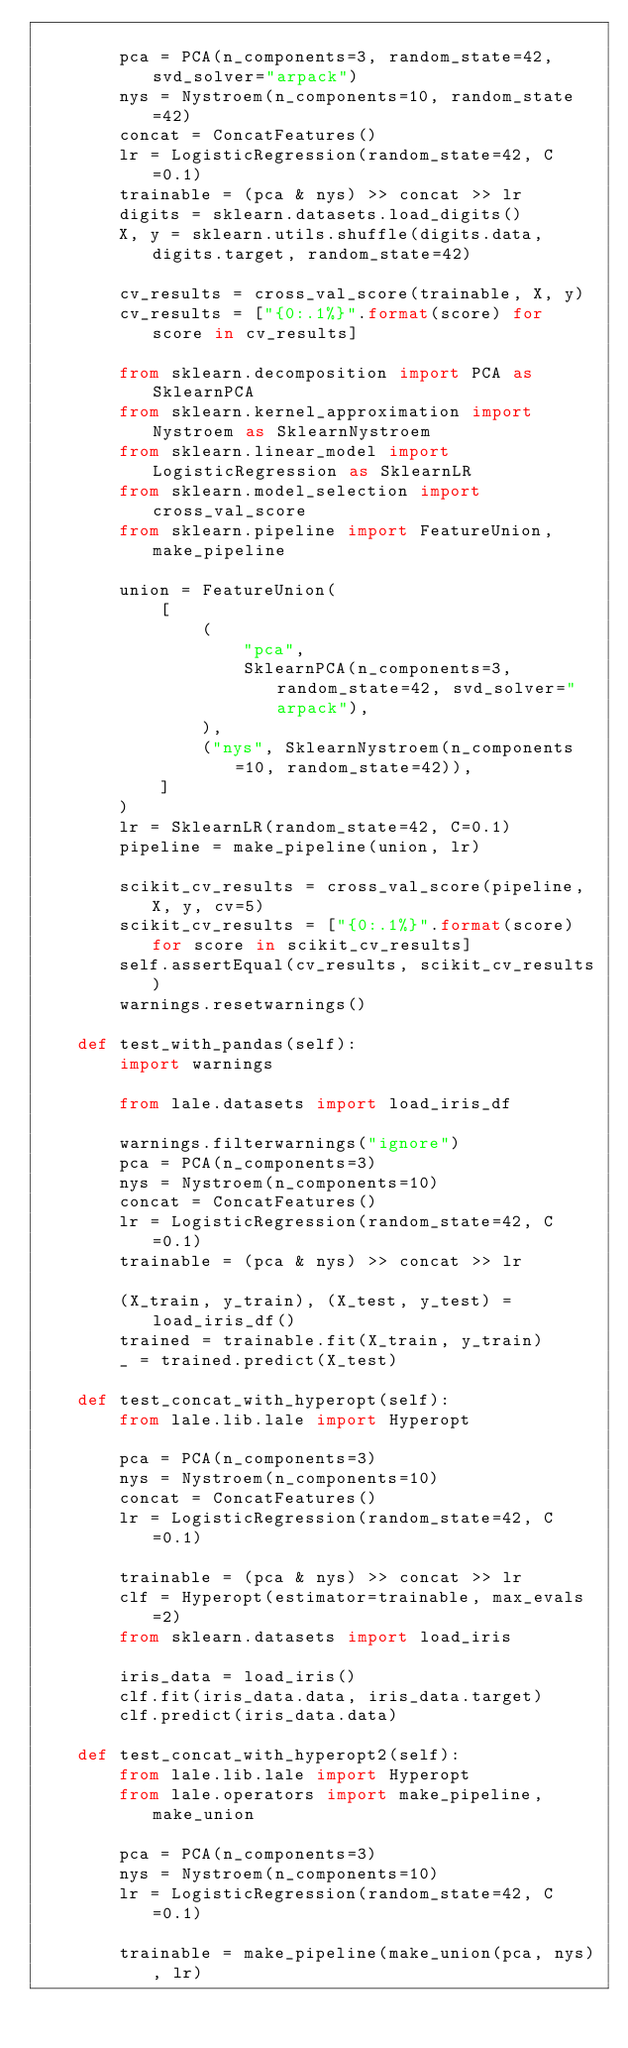Convert code to text. <code><loc_0><loc_0><loc_500><loc_500><_Python_>
        pca = PCA(n_components=3, random_state=42, svd_solver="arpack")
        nys = Nystroem(n_components=10, random_state=42)
        concat = ConcatFeatures()
        lr = LogisticRegression(random_state=42, C=0.1)
        trainable = (pca & nys) >> concat >> lr
        digits = sklearn.datasets.load_digits()
        X, y = sklearn.utils.shuffle(digits.data, digits.target, random_state=42)

        cv_results = cross_val_score(trainable, X, y)
        cv_results = ["{0:.1%}".format(score) for score in cv_results]

        from sklearn.decomposition import PCA as SklearnPCA
        from sklearn.kernel_approximation import Nystroem as SklearnNystroem
        from sklearn.linear_model import LogisticRegression as SklearnLR
        from sklearn.model_selection import cross_val_score
        from sklearn.pipeline import FeatureUnion, make_pipeline

        union = FeatureUnion(
            [
                (
                    "pca",
                    SklearnPCA(n_components=3, random_state=42, svd_solver="arpack"),
                ),
                ("nys", SklearnNystroem(n_components=10, random_state=42)),
            ]
        )
        lr = SklearnLR(random_state=42, C=0.1)
        pipeline = make_pipeline(union, lr)

        scikit_cv_results = cross_val_score(pipeline, X, y, cv=5)
        scikit_cv_results = ["{0:.1%}".format(score) for score in scikit_cv_results]
        self.assertEqual(cv_results, scikit_cv_results)
        warnings.resetwarnings()

    def test_with_pandas(self):
        import warnings

        from lale.datasets import load_iris_df

        warnings.filterwarnings("ignore")
        pca = PCA(n_components=3)
        nys = Nystroem(n_components=10)
        concat = ConcatFeatures()
        lr = LogisticRegression(random_state=42, C=0.1)
        trainable = (pca & nys) >> concat >> lr

        (X_train, y_train), (X_test, y_test) = load_iris_df()
        trained = trainable.fit(X_train, y_train)
        _ = trained.predict(X_test)

    def test_concat_with_hyperopt(self):
        from lale.lib.lale import Hyperopt

        pca = PCA(n_components=3)
        nys = Nystroem(n_components=10)
        concat = ConcatFeatures()
        lr = LogisticRegression(random_state=42, C=0.1)

        trainable = (pca & nys) >> concat >> lr
        clf = Hyperopt(estimator=trainable, max_evals=2)
        from sklearn.datasets import load_iris

        iris_data = load_iris()
        clf.fit(iris_data.data, iris_data.target)
        clf.predict(iris_data.data)

    def test_concat_with_hyperopt2(self):
        from lale.lib.lale import Hyperopt
        from lale.operators import make_pipeline, make_union

        pca = PCA(n_components=3)
        nys = Nystroem(n_components=10)
        lr = LogisticRegression(random_state=42, C=0.1)

        trainable = make_pipeline(make_union(pca, nys), lr)</code> 